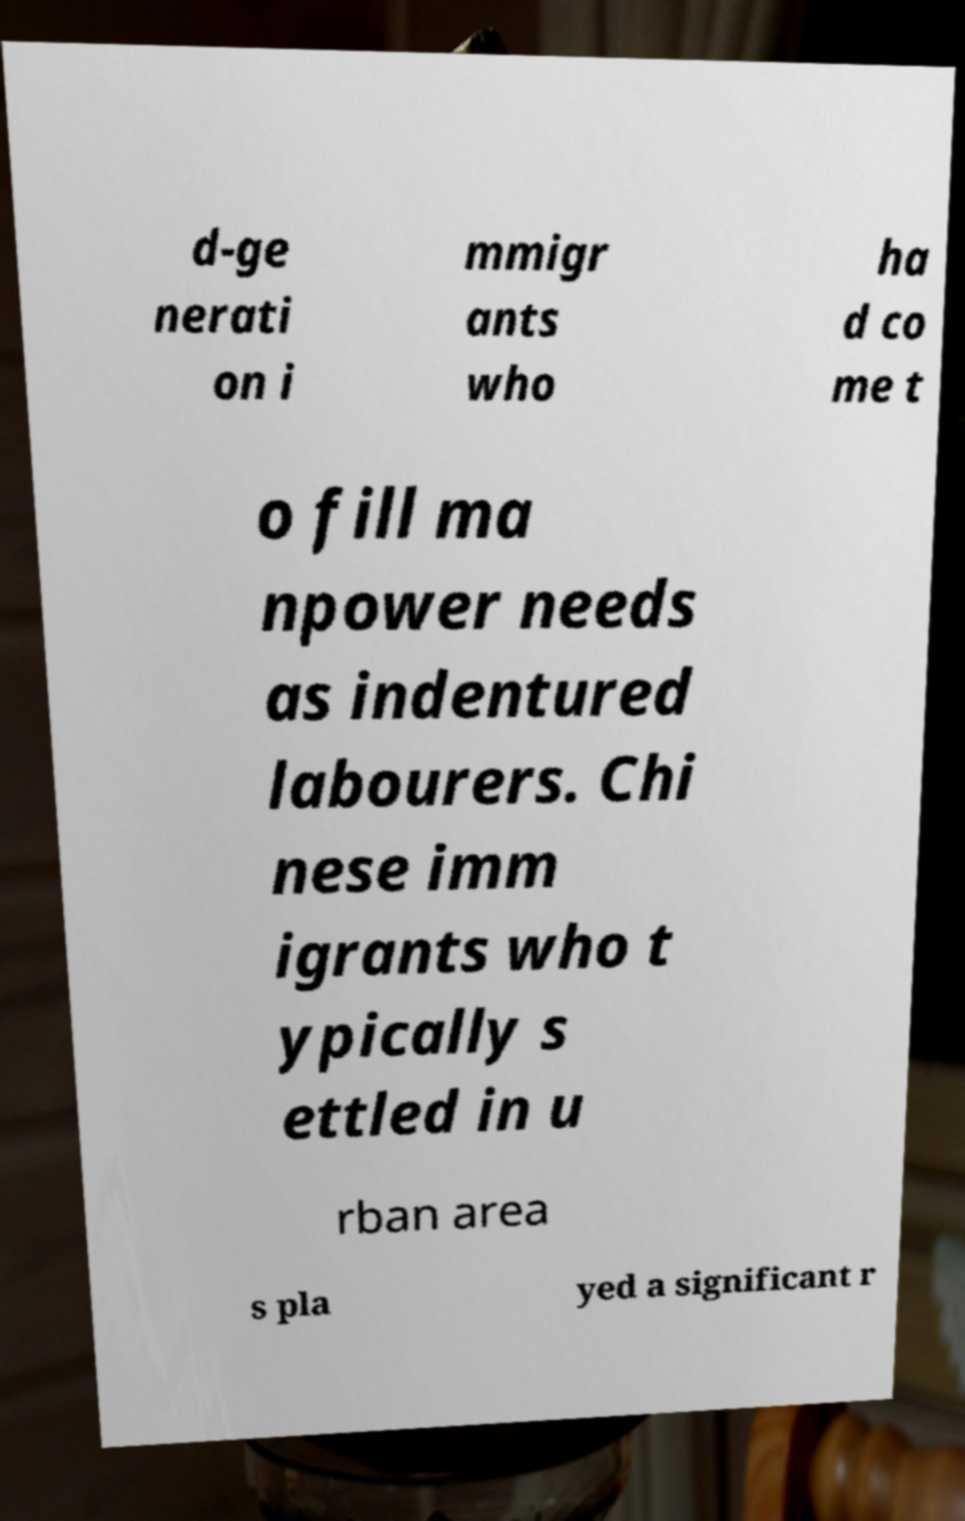Please identify and transcribe the text found in this image. d-ge nerati on i mmigr ants who ha d co me t o fill ma npower needs as indentured labourers. Chi nese imm igrants who t ypically s ettled in u rban area s pla yed a significant r 